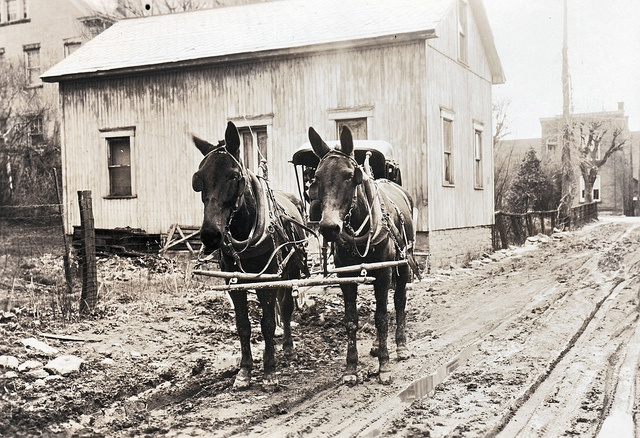Describe the objects in this image and their specific colors. I can see horse in lightgray, black, gray, and darkgray tones and horse in lightgray, black, gray, and darkgray tones in this image. 